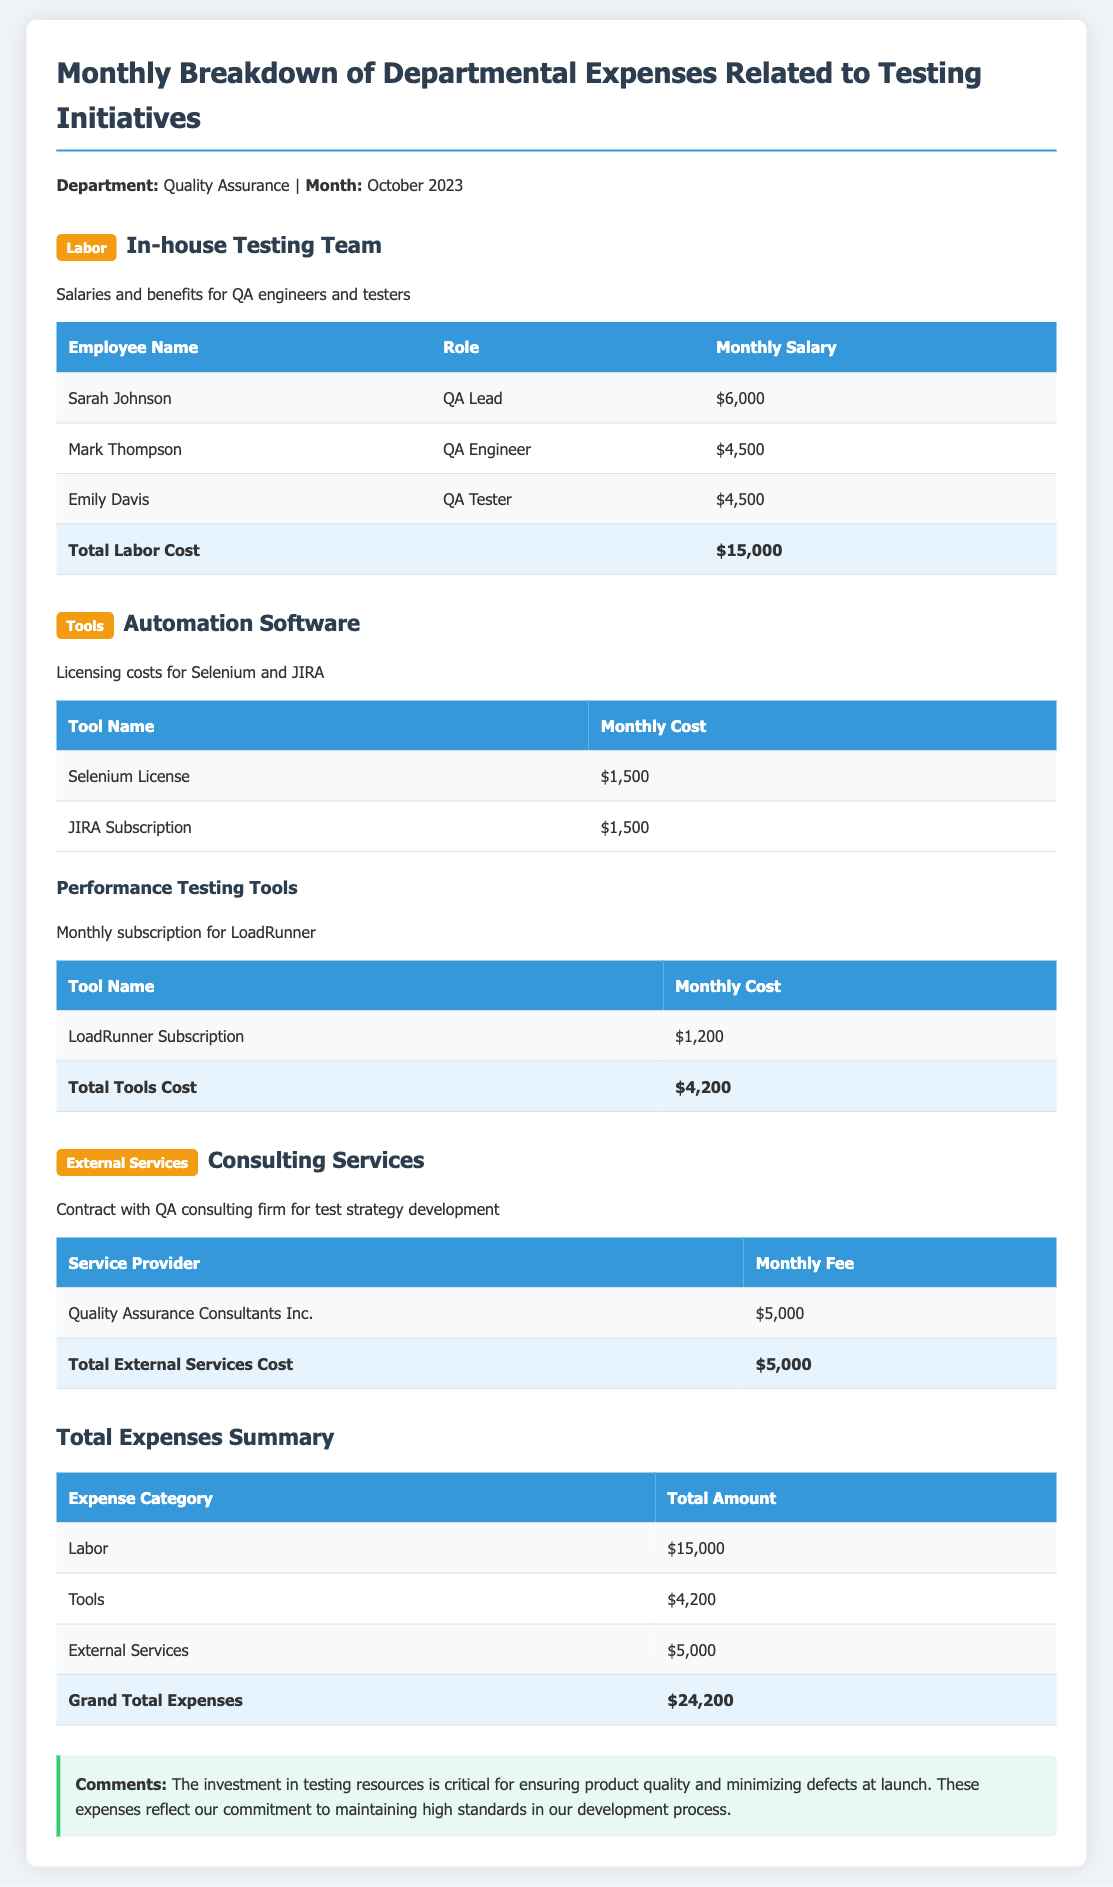What is the total labor cost? The total labor cost is found in the labor section, which sums the salaries of all employees listed.
Answer: $15,000 How much is the monthly fee for Quality Assurance Consultants Inc.? This is found in the external services section, detailing the monthly fee for the service provider.
Answer: $5,000 What is the total cost for tools? The total tools cost is calculated by summing the monthly costs of all tools listed in the document.
Answer: $4,200 Who is the QA Lead? The QA Lead is the first employee listed under the labor section, providing a specific name.
Answer: Sarah Johnson What percentage of the total expenses does labor represent? This requires reasoning based on the total expenses and labor cost to find the percentage.
Answer: 62.1% What types of external services are listed? The document specifically mentions the type of external service provided to characterize the expense.
Answer: Consulting Services What is the total number of employees listed under labor? The total number of employees can be counted from the labor section's employee list.
Answer: 3 What is the monthly cost of the Selenium License? The particular cost of the Selenium License is indicated in the tools section of the document.
Answer: $1,500 What does the comment at the end of the report emphasize? The comment summarises the importance of investment in testing resources for quality assurance.
Answer: Product quality 